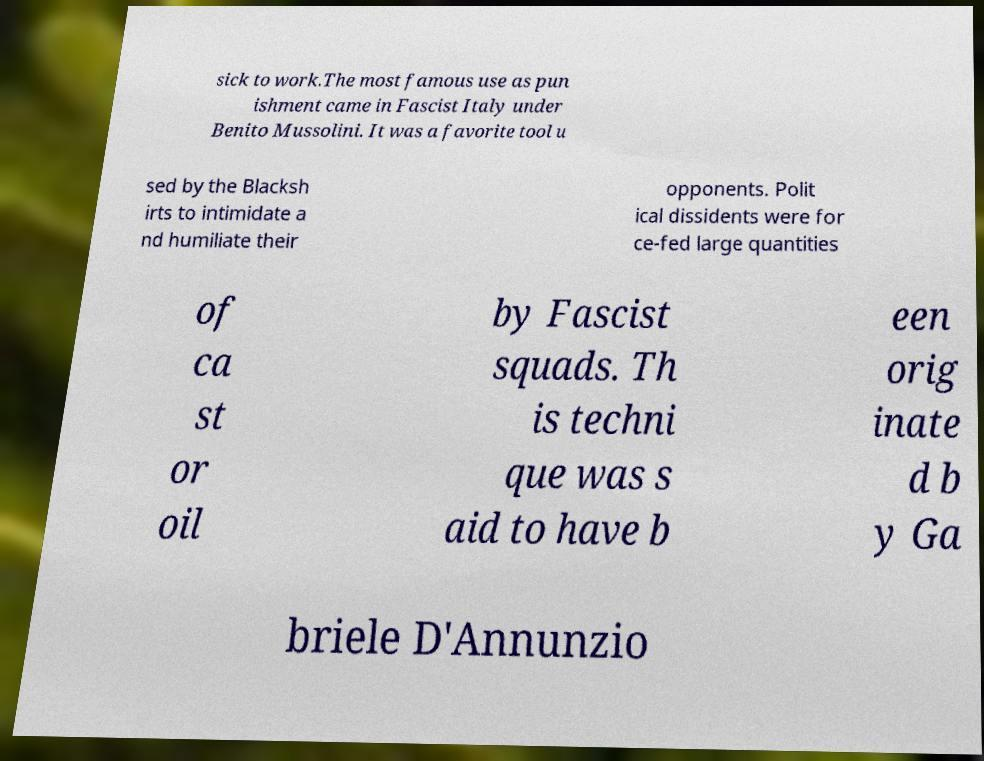For documentation purposes, I need the text within this image transcribed. Could you provide that? sick to work.The most famous use as pun ishment came in Fascist Italy under Benito Mussolini. It was a favorite tool u sed by the Blacksh irts to intimidate a nd humiliate their opponents. Polit ical dissidents were for ce-fed large quantities of ca st or oil by Fascist squads. Th is techni que was s aid to have b een orig inate d b y Ga briele D'Annunzio 